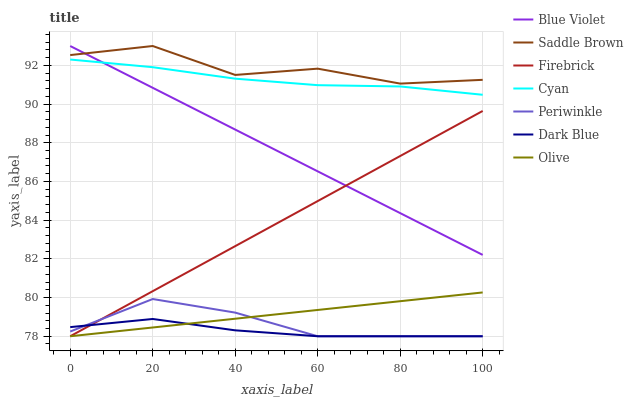Does Dark Blue have the minimum area under the curve?
Answer yes or no. Yes. Does Saddle Brown have the maximum area under the curve?
Answer yes or no. Yes. Does Periwinkle have the minimum area under the curve?
Answer yes or no. No. Does Periwinkle have the maximum area under the curve?
Answer yes or no. No. Is Firebrick the smoothest?
Answer yes or no. Yes. Is Saddle Brown the roughest?
Answer yes or no. Yes. Is Dark Blue the smoothest?
Answer yes or no. No. Is Dark Blue the roughest?
Answer yes or no. No. Does Cyan have the lowest value?
Answer yes or no. No. Does Blue Violet have the highest value?
Answer yes or no. Yes. Does Periwinkle have the highest value?
Answer yes or no. No. Is Periwinkle less than Blue Violet?
Answer yes or no. Yes. Is Saddle Brown greater than Dark Blue?
Answer yes or no. Yes. Does Blue Violet intersect Cyan?
Answer yes or no. Yes. Is Blue Violet less than Cyan?
Answer yes or no. No. Is Blue Violet greater than Cyan?
Answer yes or no. No. Does Periwinkle intersect Blue Violet?
Answer yes or no. No. 